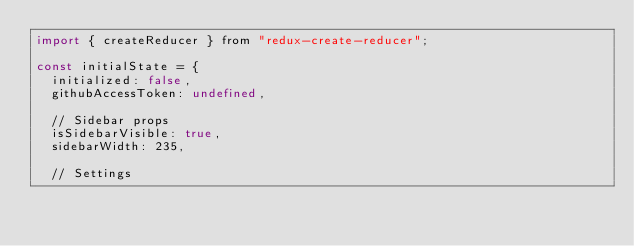Convert code to text. <code><loc_0><loc_0><loc_500><loc_500><_JavaScript_>import { createReducer } from "redux-create-reducer";

const initialState = {
  initialized: false,
  githubAccessToken: undefined,

  // Sidebar props
  isSidebarVisible: true,
  sidebarWidth: 235,

  // Settings</code> 